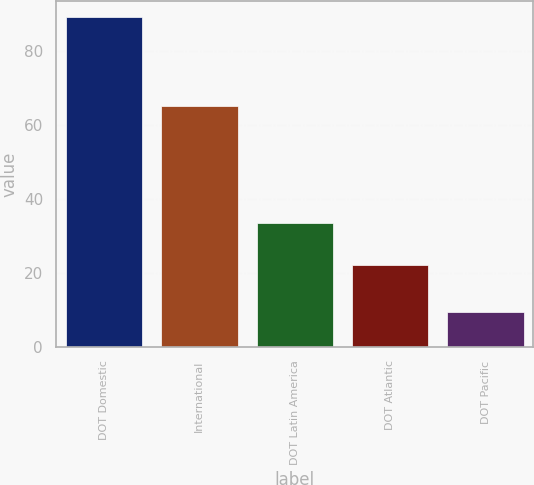<chart> <loc_0><loc_0><loc_500><loc_500><bar_chart><fcel>DOT Domestic<fcel>International<fcel>DOT Latin America<fcel>DOT Atlantic<fcel>DOT Pacific<nl><fcel>89.3<fcel>65.2<fcel>33.5<fcel>22.1<fcel>9.6<nl></chart> 